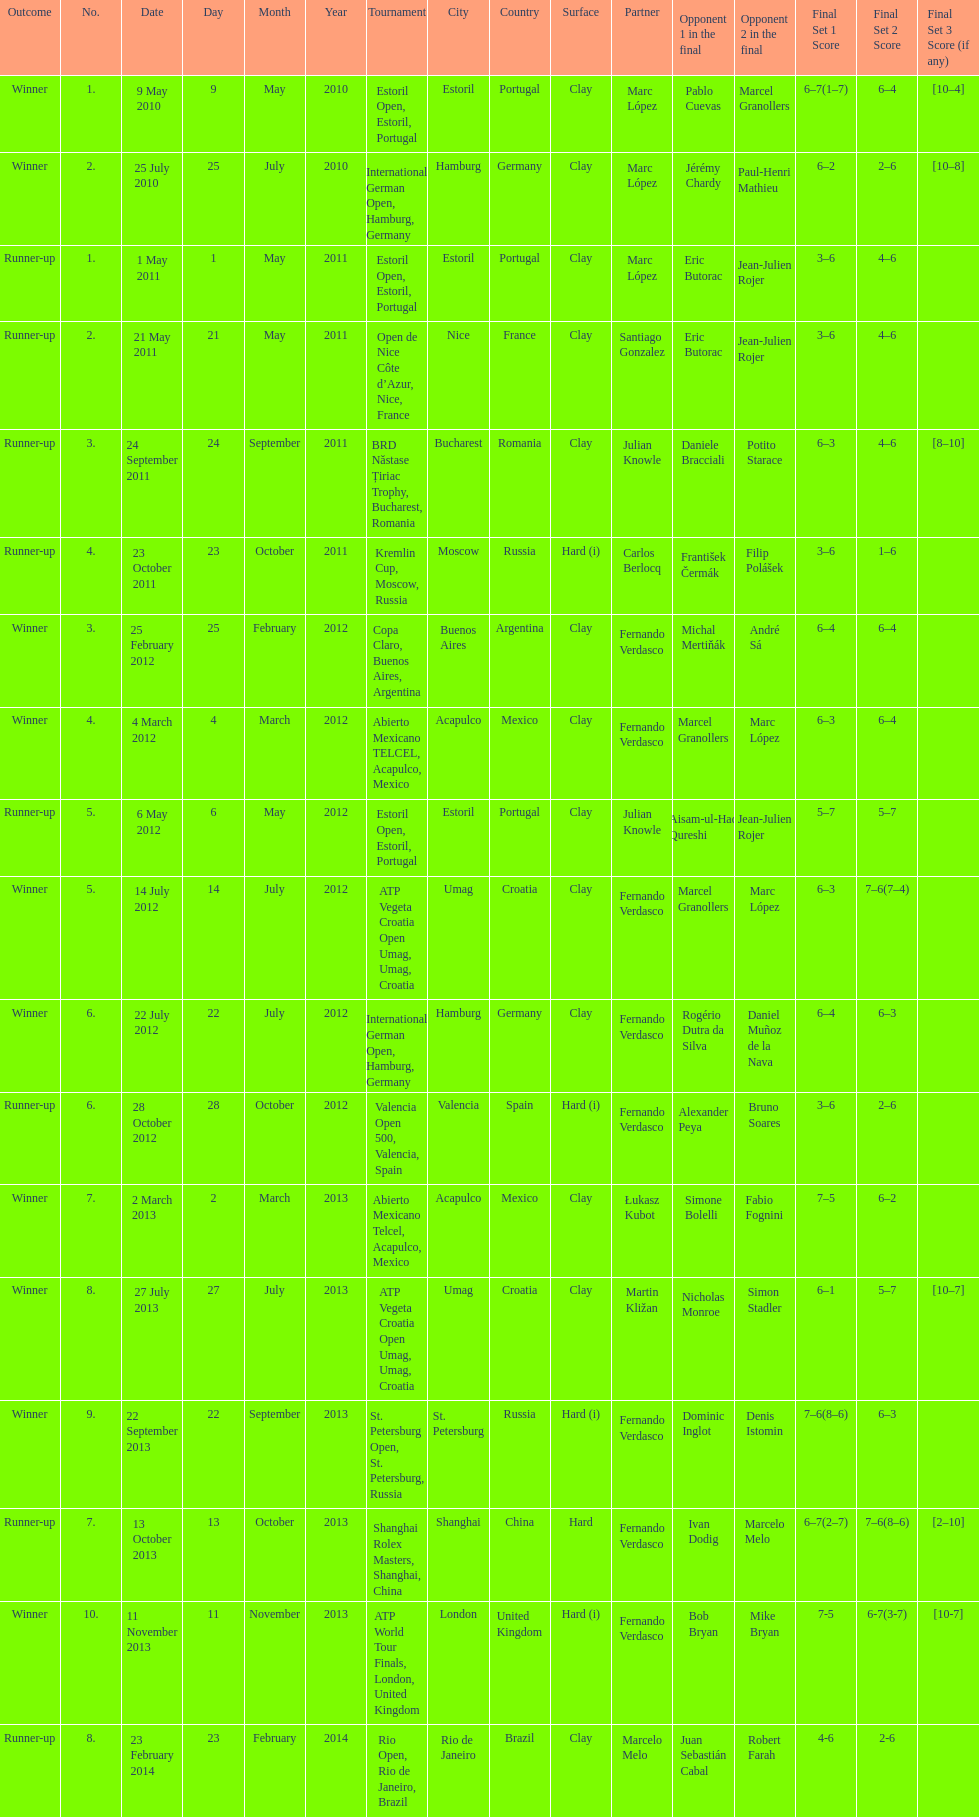Who was this player's next partner after playing with marc lopez in may 2011? Santiago Gonzalez. 